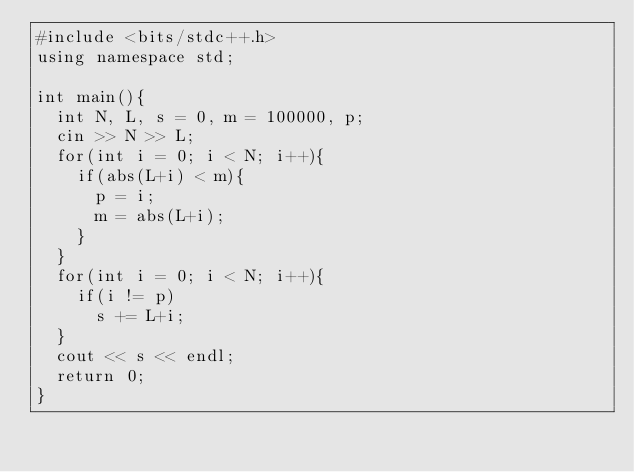<code> <loc_0><loc_0><loc_500><loc_500><_C++_>#include <bits/stdc++.h>
using namespace std;

int main(){
	int N, L, s = 0, m = 100000, p;
	cin >> N >> L;
	for(int i = 0; i < N; i++){
		if(abs(L+i) < m){
			p = i;
			m = abs(L+i);
		}
	}
	for(int i = 0; i < N; i++){
		if(i != p)
			s += L+i;
	}
	cout << s << endl;
	return 0;
}</code> 